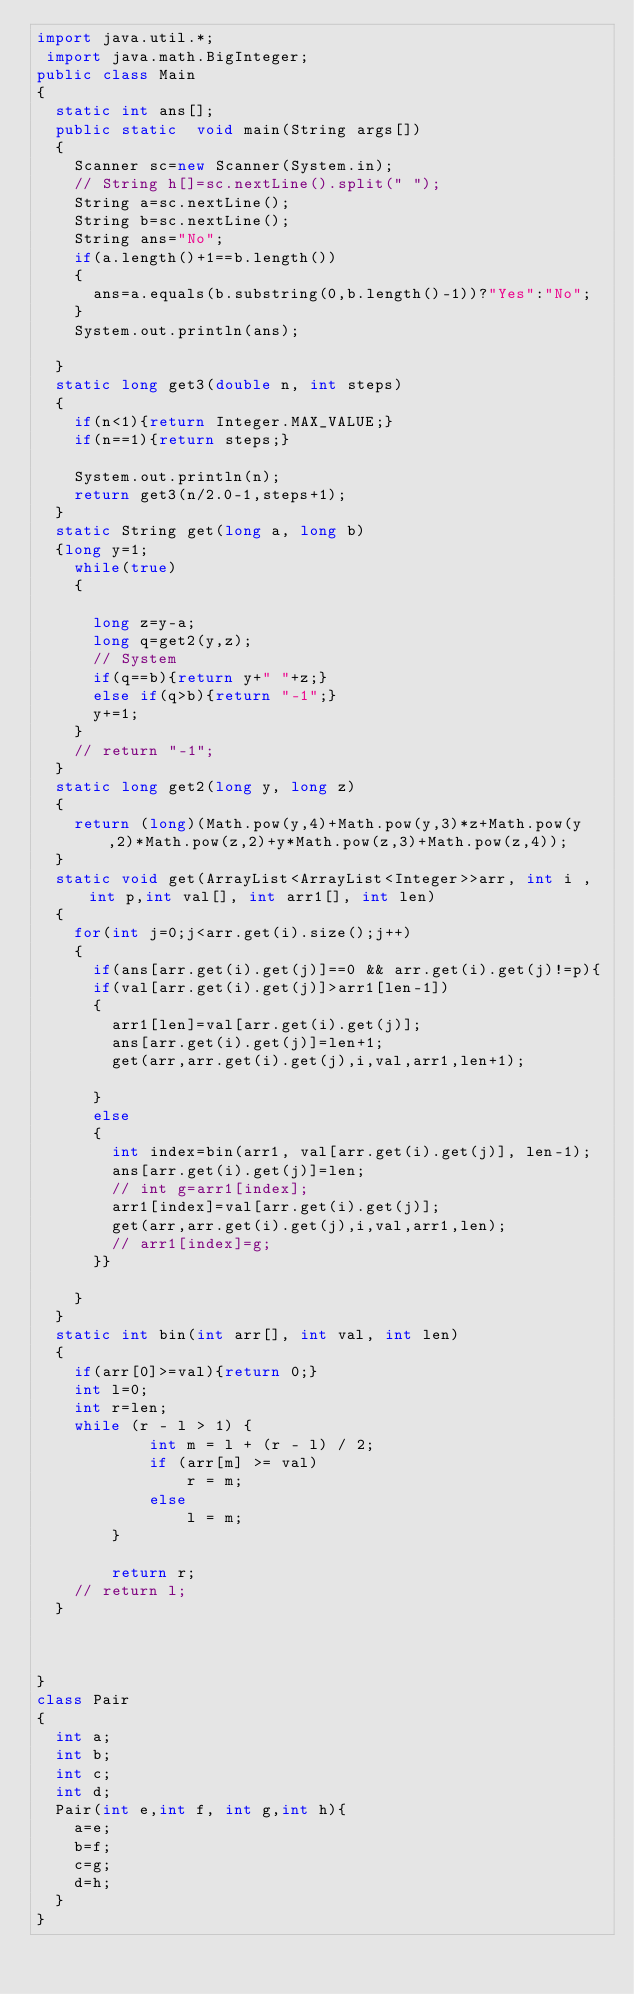Convert code to text. <code><loc_0><loc_0><loc_500><loc_500><_Java_>import java.util.*;
 import java.math.BigInteger;
public class Main
{
	static int ans[];
	public static  void main(String args[])
	{
		Scanner sc=new Scanner(System.in);
		// String h[]=sc.nextLine().split(" ");
		String a=sc.nextLine();
		String b=sc.nextLine();
		String ans="No";
		if(a.length()+1==b.length())
		{
			ans=a.equals(b.substring(0,b.length()-1))?"Yes":"No";
		}
		System.out.println(ans);
		
	}
	static long get3(double n, int steps)
	{
		if(n<1){return Integer.MAX_VALUE;}
		if(n==1){return steps;}

		System.out.println(n);
		return get3(n/2.0-1,steps+1);
	}
	static String get(long a, long b)
	{long y=1;
		while(true)
		{

			long z=y-a;
			long q=get2(y,z);
			// System
			if(q==b){return y+" "+z;}
			else if(q>b){return "-1";}
			y+=1;
		}
		// return "-1";
	}
	static long get2(long y, long z)
	{
		return (long)(Math.pow(y,4)+Math.pow(y,3)*z+Math.pow(y,2)*Math.pow(z,2)+y*Math.pow(z,3)+Math.pow(z,4));
	}
	static void get(ArrayList<ArrayList<Integer>>arr, int i , int p,int val[], int arr1[], int len)
	{
		for(int j=0;j<arr.get(i).size();j++)
		{
			if(ans[arr.get(i).get(j)]==0 && arr.get(i).get(j)!=p){
			if(val[arr.get(i).get(j)]>arr1[len-1])
			{
				arr1[len]=val[arr.get(i).get(j)];
				ans[arr.get(i).get(j)]=len+1;
				get(arr,arr.get(i).get(j),i,val,arr1,len+1);
				
			}
			else
			{
				int index=bin(arr1, val[arr.get(i).get(j)], len-1);
				ans[arr.get(i).get(j)]=len;
				// int g=arr1[index];
				arr1[index]=val[arr.get(i).get(j)];
				get(arr,arr.get(i).get(j),i,val,arr1,len);
				// arr1[index]=g;
			}}

		}
	}
	static int bin(int arr[], int val, int len)
	{
		if(arr[0]>=val){return 0;}
		int l=0;
		int r=len;
		while (r - l > 1) { 
            int m = l + (r - l) / 2; 
            if (arr[m] >= val) 
                r = m; 
            else
                l = m; 
        } 
  
        return r; 
		// return l;
	}
	
	

}
class Pair
{
	int a;
	int b;
	int c;
	int d;
	Pair(int e,int f, int g,int h){
		a=e;
		b=f;
		c=g;
		d=h;
	}
}



	
</code> 